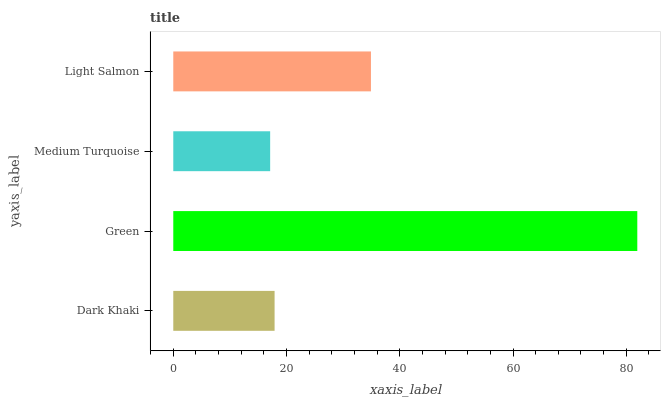Is Medium Turquoise the minimum?
Answer yes or no. Yes. Is Green the maximum?
Answer yes or no. Yes. Is Green the minimum?
Answer yes or no. No. Is Medium Turquoise the maximum?
Answer yes or no. No. Is Green greater than Medium Turquoise?
Answer yes or no. Yes. Is Medium Turquoise less than Green?
Answer yes or no. Yes. Is Medium Turquoise greater than Green?
Answer yes or no. No. Is Green less than Medium Turquoise?
Answer yes or no. No. Is Light Salmon the high median?
Answer yes or no. Yes. Is Dark Khaki the low median?
Answer yes or no. Yes. Is Dark Khaki the high median?
Answer yes or no. No. Is Medium Turquoise the low median?
Answer yes or no. No. 